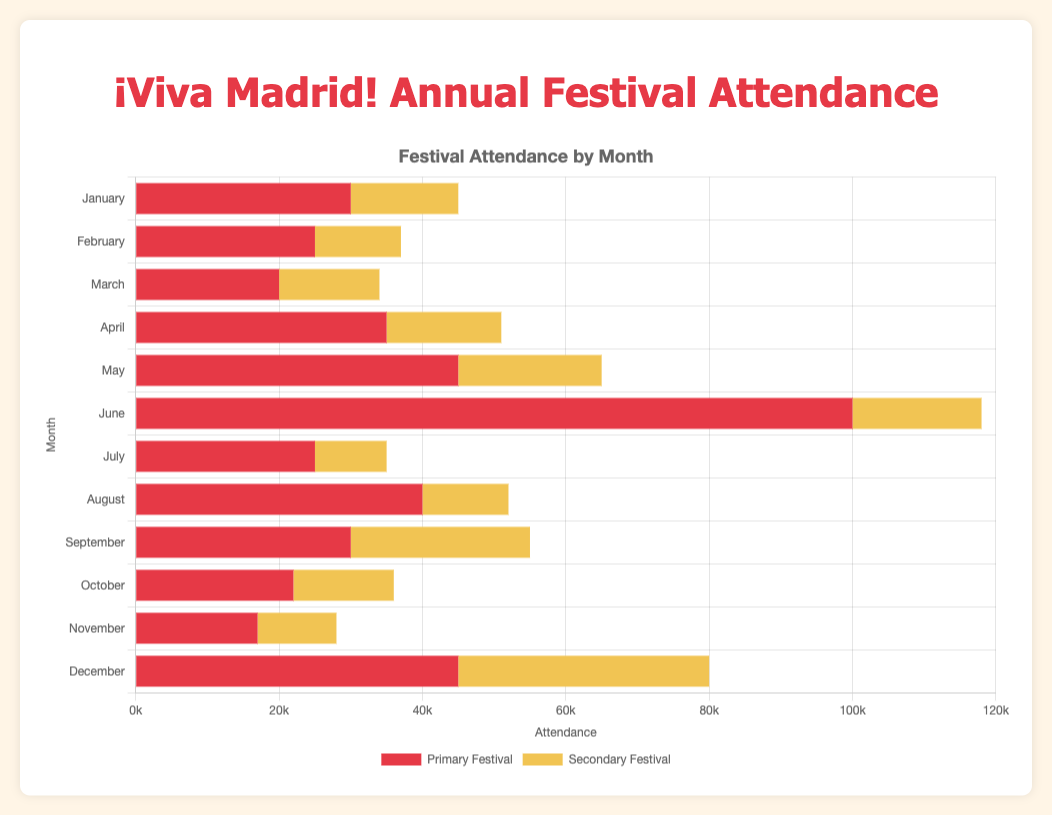What is the total attendance of festivals in June? Sum the attendance of the Pride Parade and Summa Art Fair in June (100,000 + 18,000). So, the total attendance is 118,000.
Answer: 118,000 Which month has the highest total festival attendance? Identify the month with the tallest bars combined in length. June has the Pride Parade, which alone has a high attendance of 100,000, making it the highest.
Answer: June How does the attendance of the San Isidro Festival in May compare to the attendance of the Christmas Market in December? The attendance of the San Isidro Festival is 45,000 and the Christmas Market is also 45,000. Both are equal.
Answer: Equal What is the difference in attendance between La Noche en Blanco and JazzMadrid in October? Subtract the attendance of JazzMadrid from La Noche en Blanco (22,000 - 14,000). The difference is 8,000.
Answer: 8,000 In which month does the secondary festival (yellow bars) have the highest attendance? Look for the longest yellow bar in each month; December’s New Year's Eve Party has 35,000, which is the highest among all secondary festivals.
Answer: December What is the average attendance for the primary festivals in January? Sum the attendance for the primary festivals in January (Three Kings Parade: 30,000 + Gastrofestival: 15,000) and divide by 2. The average attendance is (30,000 + 15,000) / 2 = 22,500.
Answer: 22,500 Which month has the lowest total attendance for its secondary festival? Identify the month with the shortest yellow bar. November’s Madrid Science Week at 11,000 has the lowest attendance.
Answer: November How does the combined attendance for festivals in August compare to that of February? January: Fiestas de la Paloma (40,000) + Fringe Festival (12,000) = 52,000; February: Carnival (25,000) + Madrid Design Festival (12,000) = 37,000. August has a higher combined attendance. 52,000 is greater than 37,000.
Answer: August What percentage of the total attendance in December is attributed to the Christmas Market? Total attendance in December (Christmas Market: 45,000 + New Year's Eve Party: 35,000) = 80,000. Percentage for Christmas Market is (45,000 / 80,000) * 100 = 56.25%.
Answer: 56.25% 